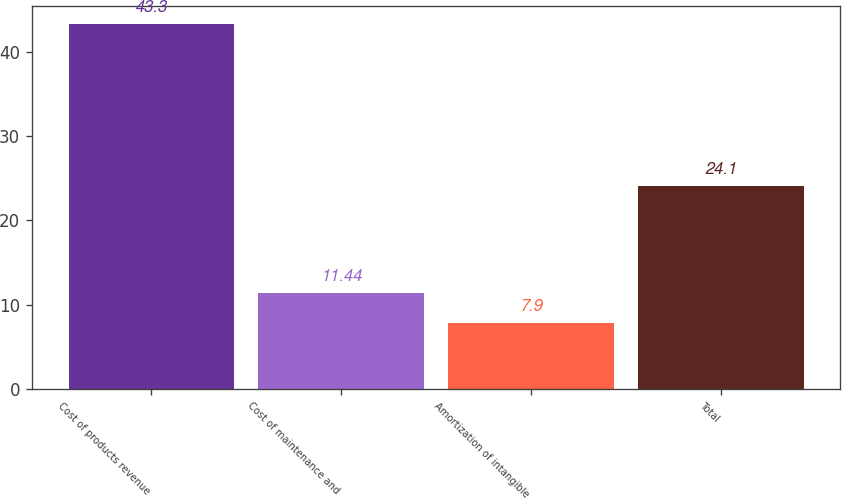Convert chart to OTSL. <chart><loc_0><loc_0><loc_500><loc_500><bar_chart><fcel>Cost of products revenue<fcel>Cost of maintenance and<fcel>Amortization of intangible<fcel>Total<nl><fcel>43.3<fcel>11.44<fcel>7.9<fcel>24.1<nl></chart> 